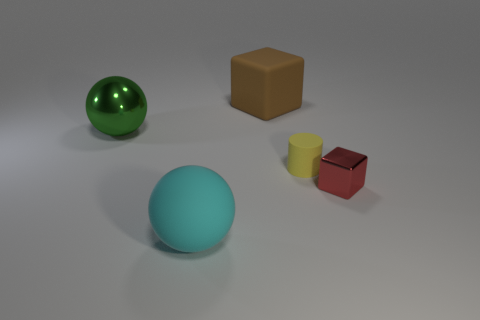Add 3 large gray cylinders. How many objects exist? 8 Subtract all spheres. How many objects are left? 3 Subtract all tiny things. Subtract all tiny yellow cylinders. How many objects are left? 2 Add 1 tiny yellow matte cylinders. How many tiny yellow matte cylinders are left? 2 Add 3 large green metal things. How many large green metal things exist? 4 Subtract 0 purple spheres. How many objects are left? 5 